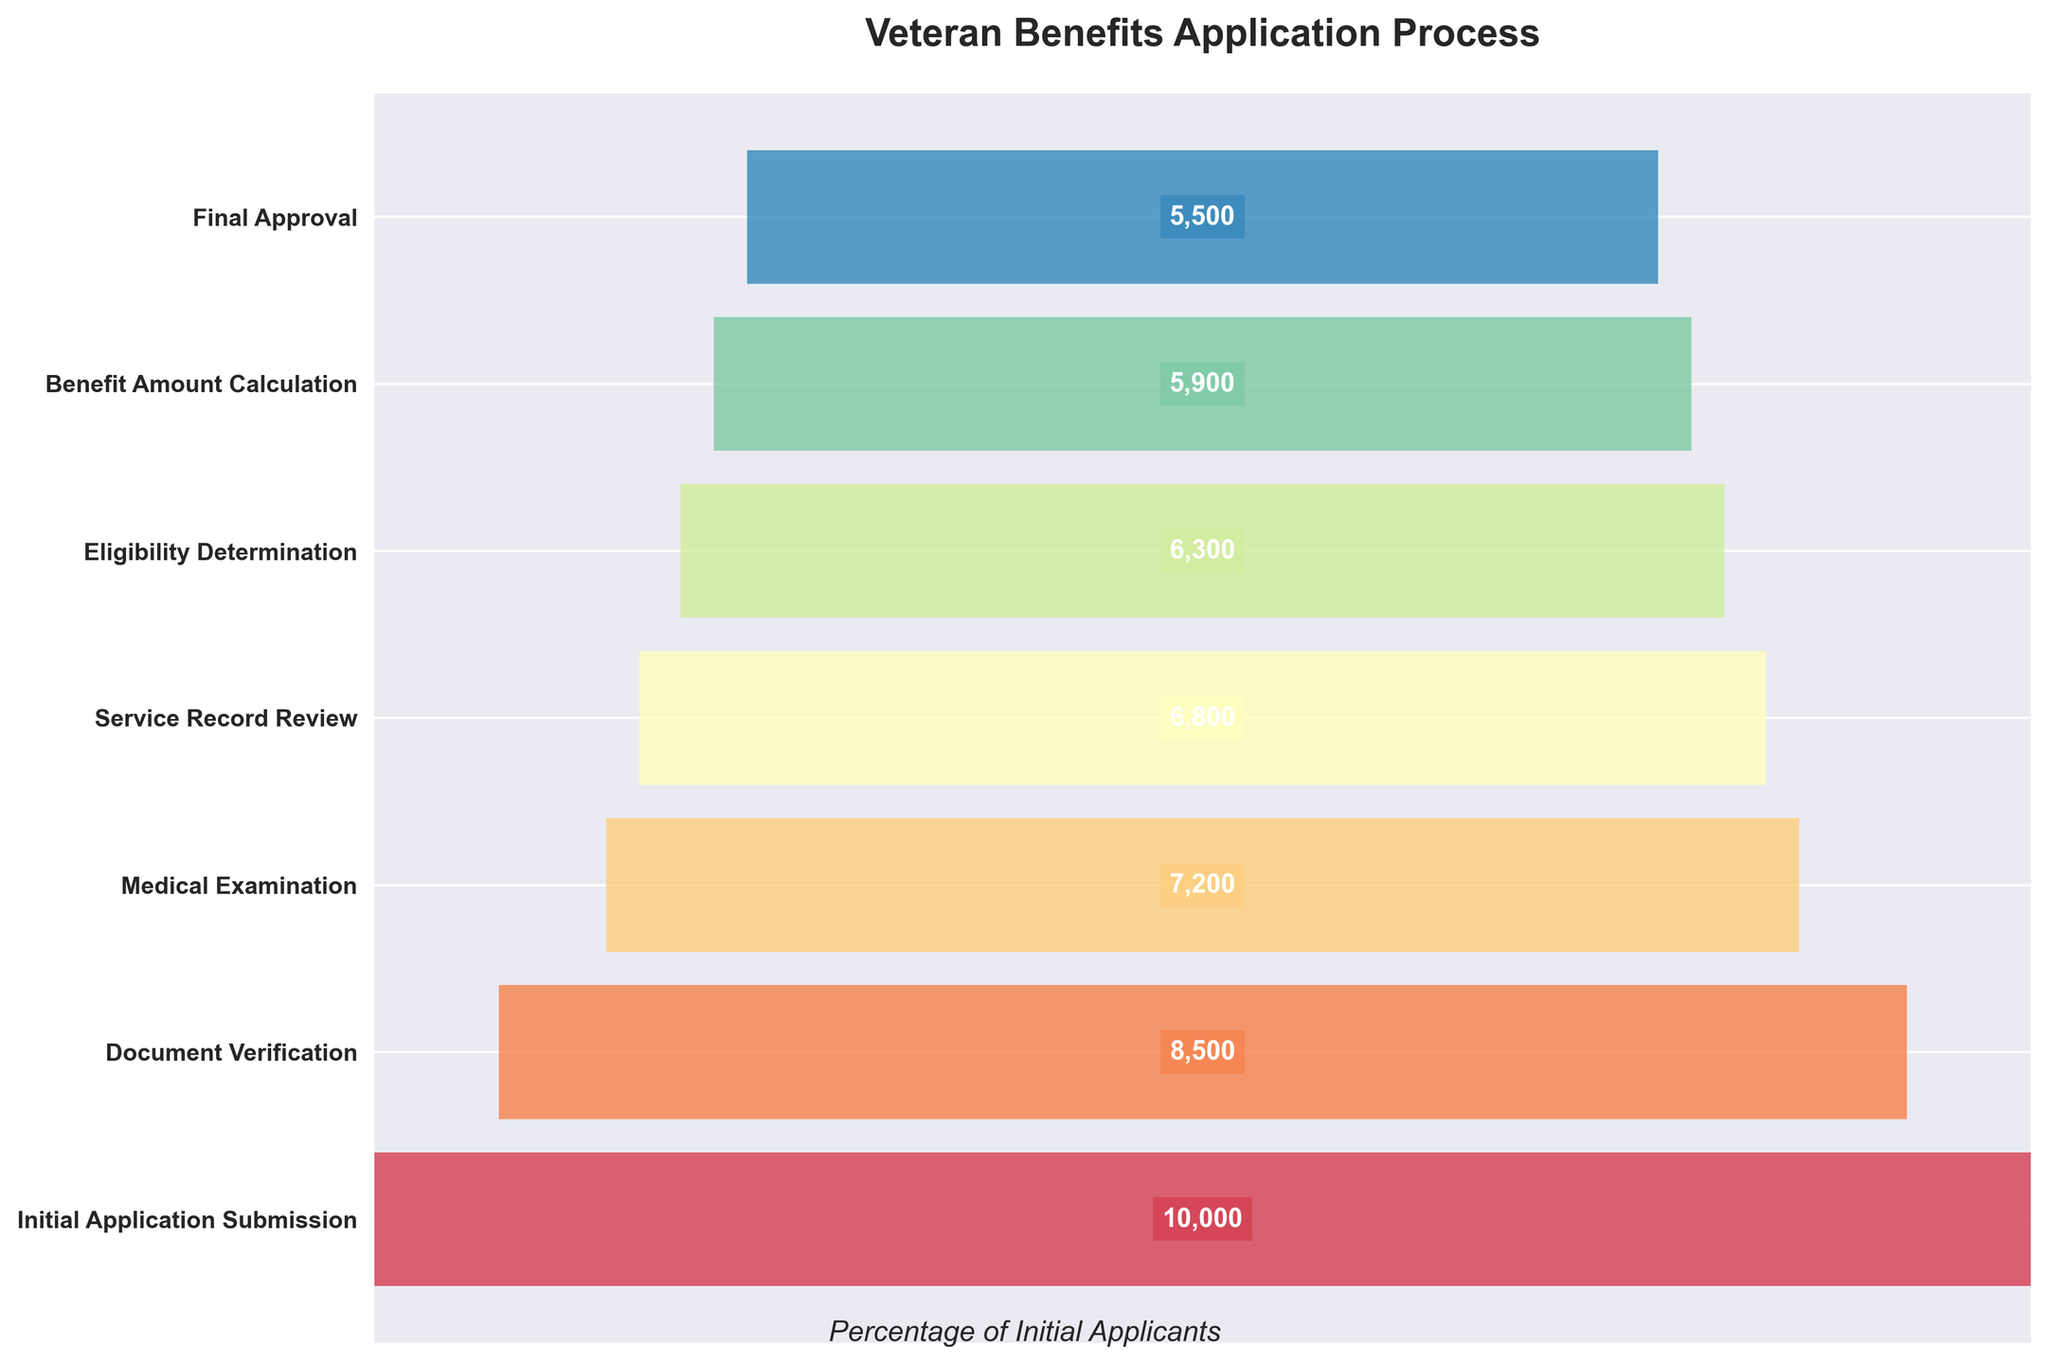What's the title of the funnel chart? The title of a chart is usually displayed at the top and provides a brief summary of the chart's content. In this figure, the title is positioned prominently to immediately inform about the nature of the data being presented.
Answer: Veteran Benefits Application Process How many veterans initially submitted the application? The first step of the funnel chart represents the initial number of applicants. According to the data, the "Initial Application Submission" step has an associated number.
Answer: 10,000 By how much does the number of veterans decrease from the "Initial Application Submission" to "Medical Examination"? To find the decrease, subtract the number of veterans in the "Medical Examination" step from the number in the "Initial Application Submission" step: 10,000 - 7,200.
Answer: 2,800 What is the final approval number for veteran applications? The last stage of the funnel, "Final Approval," gives the final count of applications that were approved after completing all previous steps.
Answer: 5,500 How many veterans do not pass the "Document Verification" stage? Subtract the number of veterans at the "Document Verification" stage from the number at the "Initial Application Submission" stage to get the drop-off: 10,000 - 8,500.
Answer: 1,500 What is the overall approval rate of veteran benefit applications from initial submission to final approval? The approval rate is calculated as (Final Approval / Initial Application Submission) * 100: (5,500 / 10,000) * 100.
Answer: 55% How many veterans are reviewed during the "Service Record Review" stage? The number of veterans reviewed at the "Service Record Review" stage is directly given by that step in the funnel chart.
Answer: 6,800 Which stage visually appears to have the highest width in the funnel chart? Observing the bar width in the funnel chart indicates which stage has the highest number of veterans remaining. The stage with the widest bar (furthest to the left and right) is at the beginning.
Answer: Initial Application Submission Compare the number of veterans at the "Medical Examination" stage to those at the "Eligibility Determination" stage. Is the number at "Medical Examination" greater than, less than, or equal to the number at "Eligibility Determination"? Compare the numbers at each stage:
- Medical Examination: 7,200
- Eligibility Determination: 6,300
The number of veterans at the Medical Examination stage is greater than at the Eligibility Determination stage.
Answer: Greater What percentage of veterans make it through the "Eligibility Determination" stage compared to those who begin at the "Initial Application Submission" stage? The percentage can be calculated as (Eligibility Determination / Initial Application Submission) * 100: (6,300 / 10,000) * 100.
Answer: 63% 